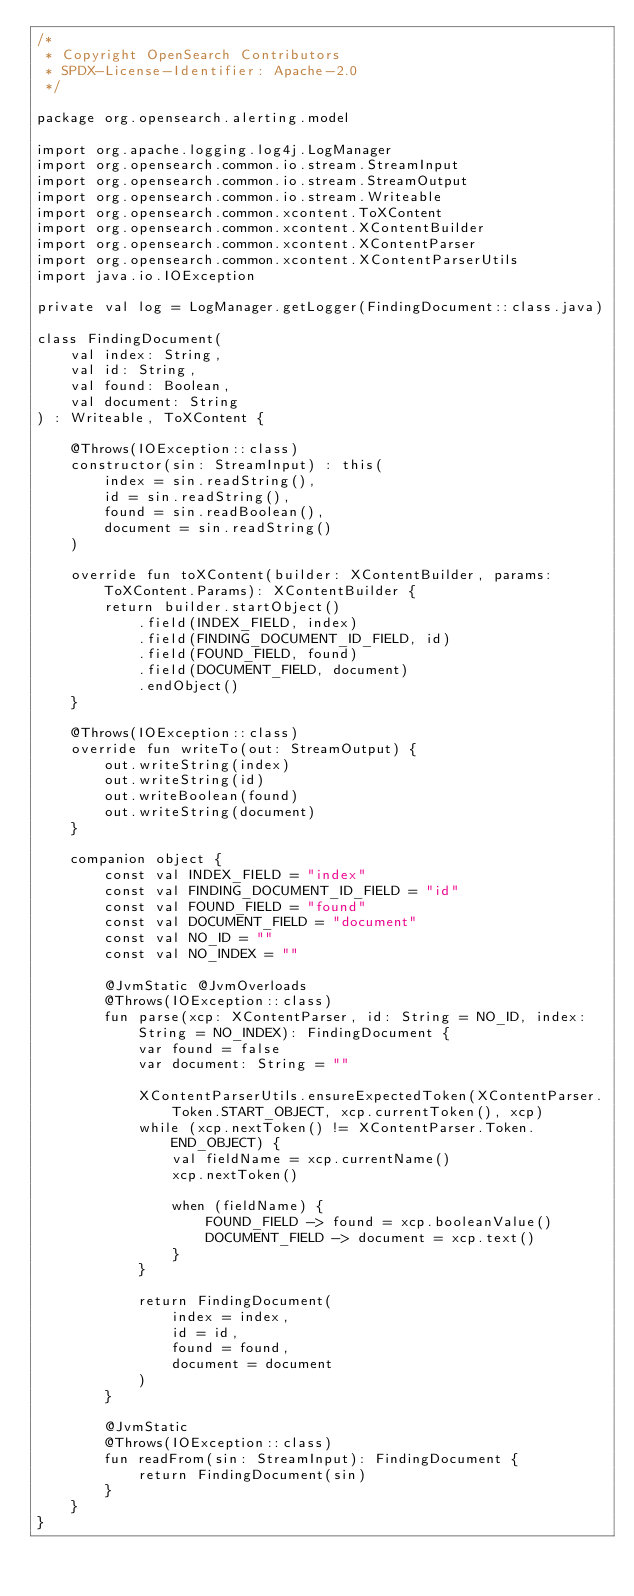Convert code to text. <code><loc_0><loc_0><loc_500><loc_500><_Kotlin_>/*
 * Copyright OpenSearch Contributors
 * SPDX-License-Identifier: Apache-2.0
 */

package org.opensearch.alerting.model

import org.apache.logging.log4j.LogManager
import org.opensearch.common.io.stream.StreamInput
import org.opensearch.common.io.stream.StreamOutput
import org.opensearch.common.io.stream.Writeable
import org.opensearch.common.xcontent.ToXContent
import org.opensearch.common.xcontent.XContentBuilder
import org.opensearch.common.xcontent.XContentParser
import org.opensearch.common.xcontent.XContentParserUtils
import java.io.IOException

private val log = LogManager.getLogger(FindingDocument::class.java)

class FindingDocument(
    val index: String,
    val id: String,
    val found: Boolean,
    val document: String
) : Writeable, ToXContent {

    @Throws(IOException::class)
    constructor(sin: StreamInput) : this(
        index = sin.readString(),
        id = sin.readString(),
        found = sin.readBoolean(),
        document = sin.readString()
    )

    override fun toXContent(builder: XContentBuilder, params: ToXContent.Params): XContentBuilder {
        return builder.startObject()
            .field(INDEX_FIELD, index)
            .field(FINDING_DOCUMENT_ID_FIELD, id)
            .field(FOUND_FIELD, found)
            .field(DOCUMENT_FIELD, document)
            .endObject()
    }

    @Throws(IOException::class)
    override fun writeTo(out: StreamOutput) {
        out.writeString(index)
        out.writeString(id)
        out.writeBoolean(found)
        out.writeString(document)
    }

    companion object {
        const val INDEX_FIELD = "index"
        const val FINDING_DOCUMENT_ID_FIELD = "id"
        const val FOUND_FIELD = "found"
        const val DOCUMENT_FIELD = "document"
        const val NO_ID = ""
        const val NO_INDEX = ""

        @JvmStatic @JvmOverloads
        @Throws(IOException::class)
        fun parse(xcp: XContentParser, id: String = NO_ID, index: String = NO_INDEX): FindingDocument {
            var found = false
            var document: String = ""

            XContentParserUtils.ensureExpectedToken(XContentParser.Token.START_OBJECT, xcp.currentToken(), xcp)
            while (xcp.nextToken() != XContentParser.Token.END_OBJECT) {
                val fieldName = xcp.currentName()
                xcp.nextToken()

                when (fieldName) {
                    FOUND_FIELD -> found = xcp.booleanValue()
                    DOCUMENT_FIELD -> document = xcp.text()
                }
            }

            return FindingDocument(
                index = index,
                id = id,
                found = found,
                document = document
            )
        }

        @JvmStatic
        @Throws(IOException::class)
        fun readFrom(sin: StreamInput): FindingDocument {
            return FindingDocument(sin)
        }
    }
}
</code> 